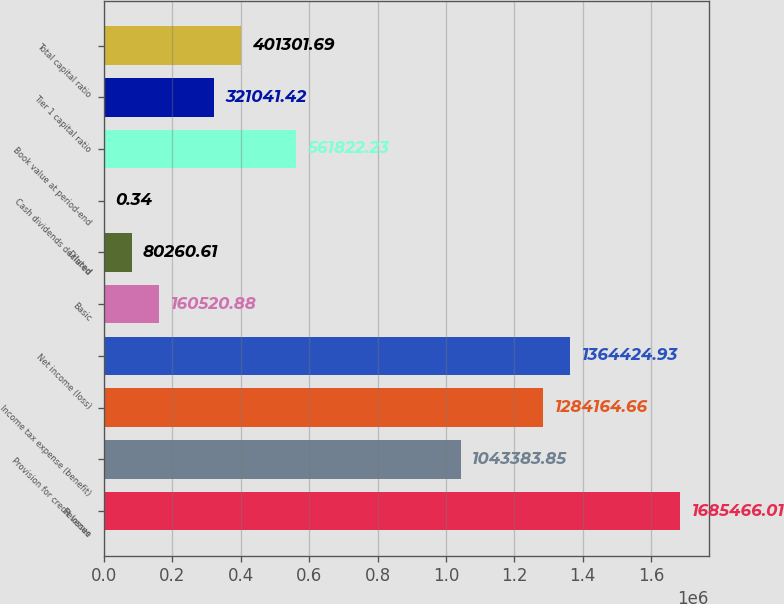<chart> <loc_0><loc_0><loc_500><loc_500><bar_chart><fcel>Revenue<fcel>Provision for credit losses<fcel>Income tax expense (benefit)<fcel>Net income (loss)<fcel>Basic<fcel>Diluted<fcel>Cash dividends declared<fcel>Book value at period-end<fcel>Tier 1 capital ratio<fcel>Total capital ratio<nl><fcel>1.68547e+06<fcel>1.04338e+06<fcel>1.28416e+06<fcel>1.36442e+06<fcel>160521<fcel>80260.6<fcel>0.34<fcel>561822<fcel>321041<fcel>401302<nl></chart> 